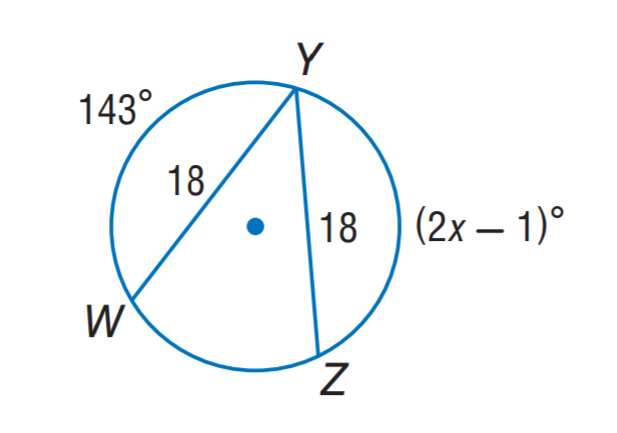Answer the mathemtical geometry problem and directly provide the correct option letter.
Question: Find x.
Choices: A: 72 B: 82 C: 84 D: 143 A 